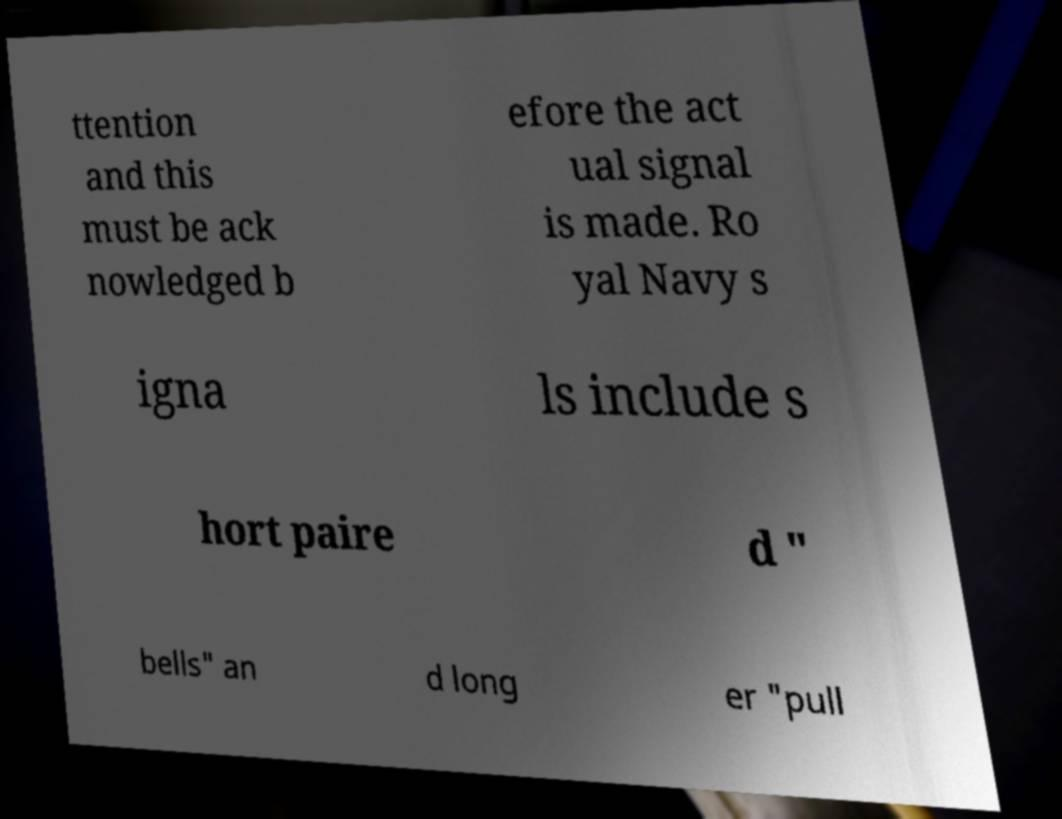Can you accurately transcribe the text from the provided image for me? ttention and this must be ack nowledged b efore the act ual signal is made. Ro yal Navy s igna ls include s hort paire d " bells" an d long er "pull 